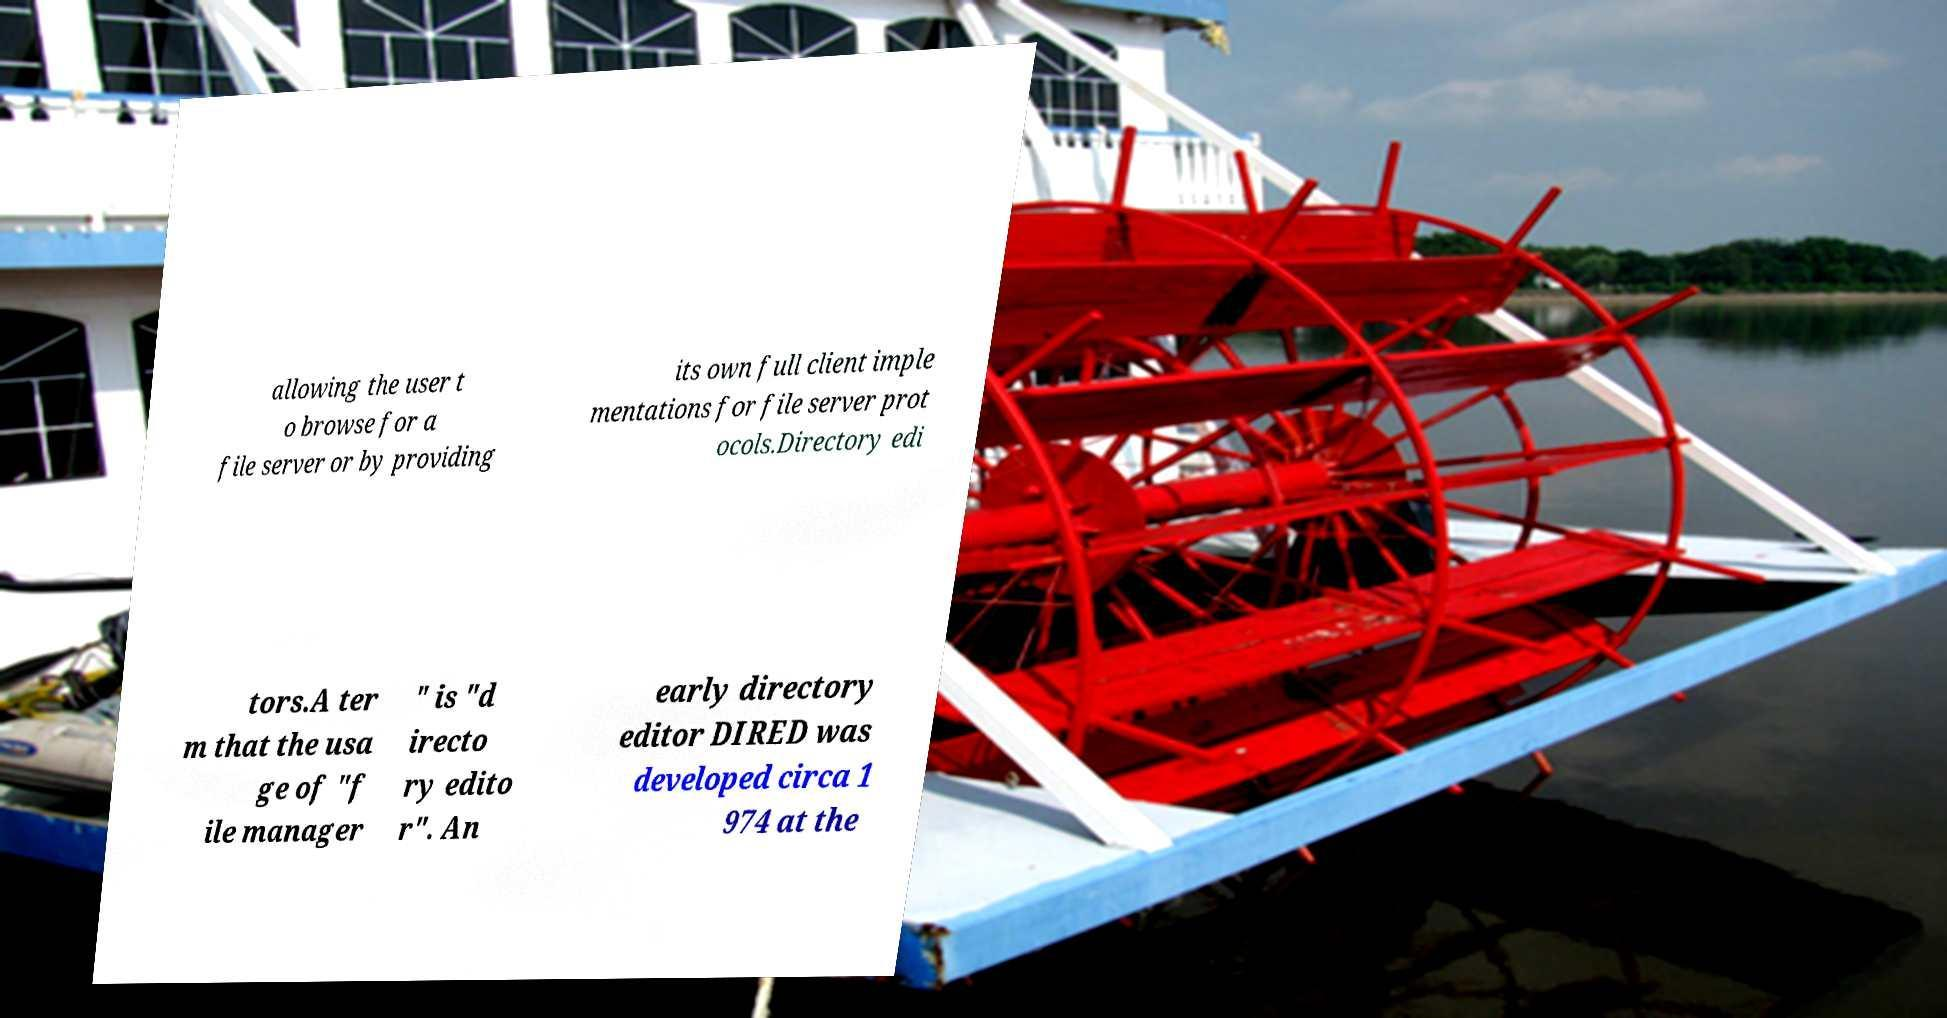Please read and relay the text visible in this image. What does it say? allowing the user t o browse for a file server or by providing its own full client imple mentations for file server prot ocols.Directory edi tors.A ter m that the usa ge of "f ile manager " is "d irecto ry edito r". An early directory editor DIRED was developed circa 1 974 at the 